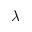Convert formula to latex. <formula><loc_0><loc_0><loc_500><loc_500>\lambda</formula> 